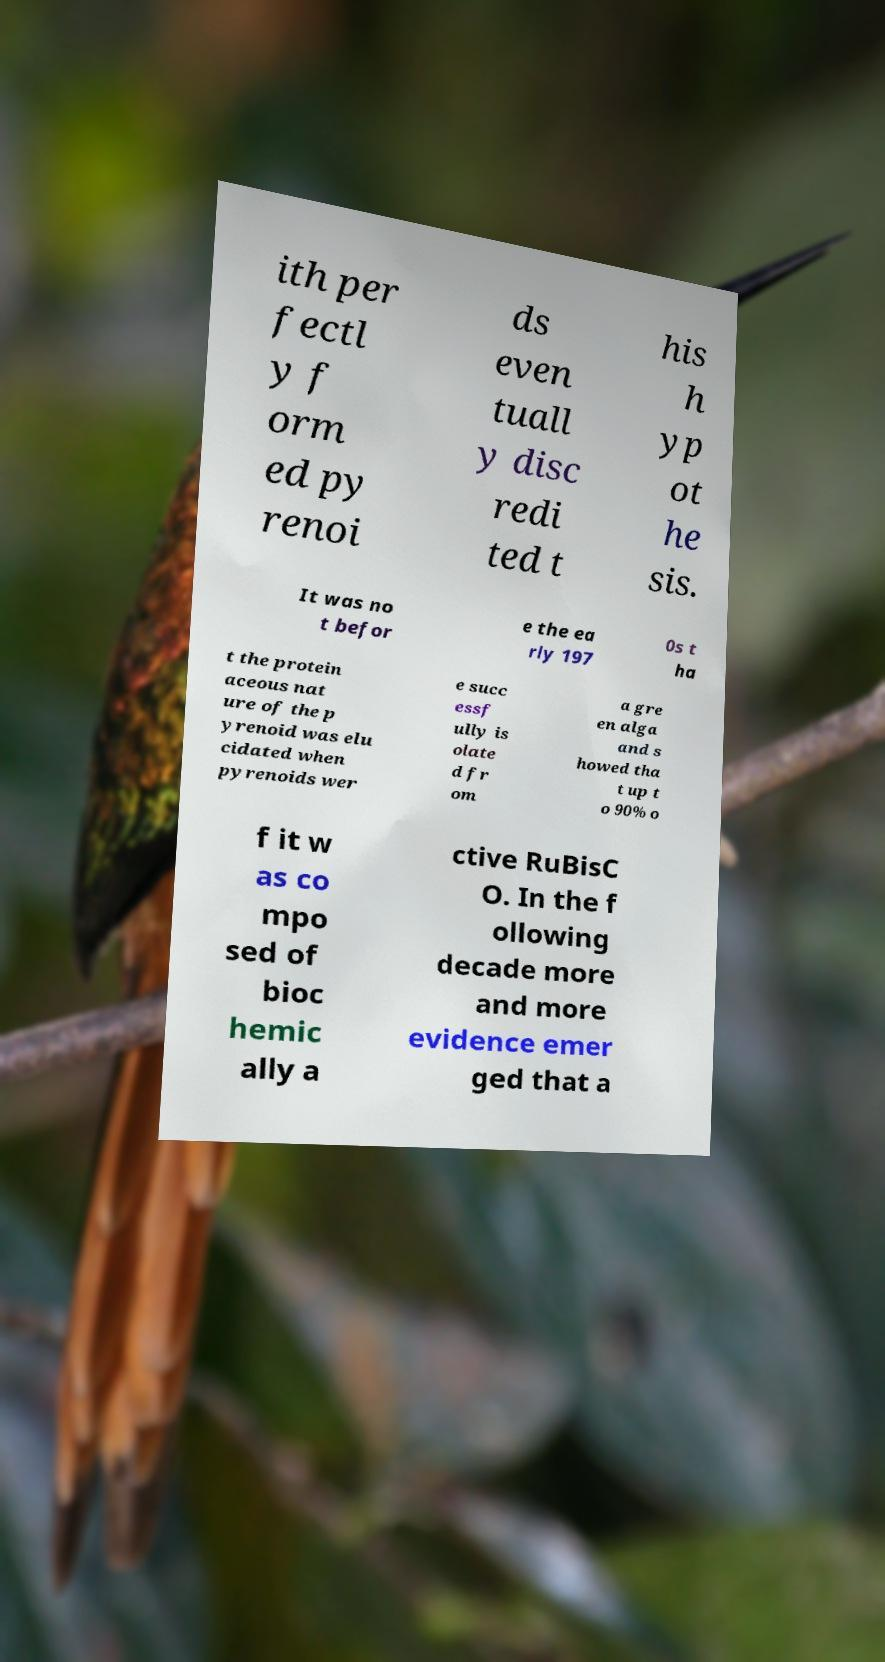Please read and relay the text visible in this image. What does it say? ith per fectl y f orm ed py renoi ds even tuall y disc redi ted t his h yp ot he sis. It was no t befor e the ea rly 197 0s t ha t the protein aceous nat ure of the p yrenoid was elu cidated when pyrenoids wer e succ essf ully is olate d fr om a gre en alga and s howed tha t up t o 90% o f it w as co mpo sed of bioc hemic ally a ctive RuBisC O. In the f ollowing decade more and more evidence emer ged that a 